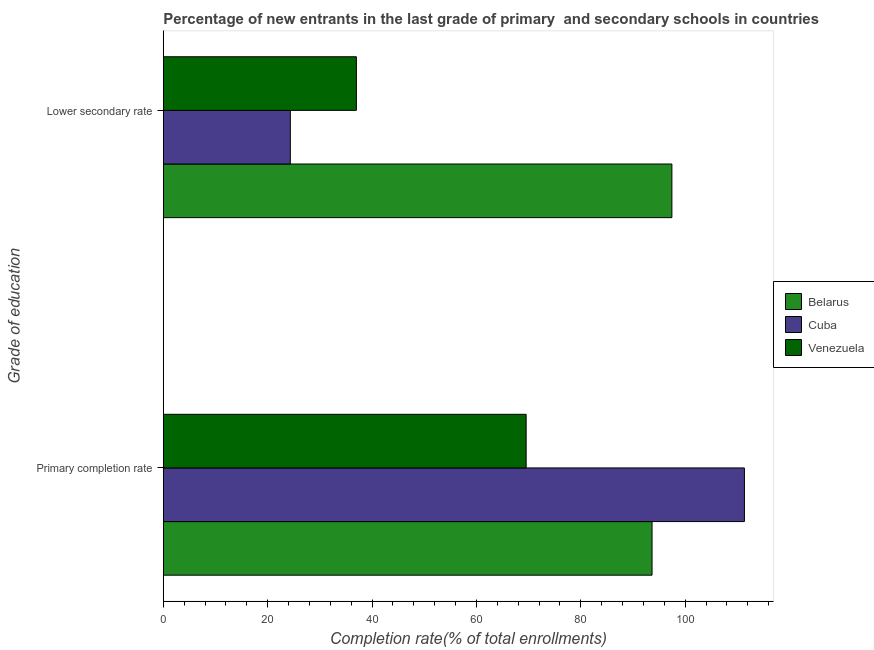How many different coloured bars are there?
Offer a very short reply. 3. How many bars are there on the 1st tick from the top?
Offer a terse response. 3. What is the label of the 1st group of bars from the top?
Ensure brevity in your answer.  Lower secondary rate. What is the completion rate in primary schools in Belarus?
Your answer should be very brief. 93.64. Across all countries, what is the maximum completion rate in primary schools?
Offer a terse response. 111.34. Across all countries, what is the minimum completion rate in secondary schools?
Provide a short and direct response. 24.34. In which country was the completion rate in secondary schools maximum?
Make the answer very short. Belarus. In which country was the completion rate in primary schools minimum?
Your response must be concise. Venezuela. What is the total completion rate in secondary schools in the graph?
Provide a succinct answer. 158.78. What is the difference between the completion rate in primary schools in Belarus and that in Venezuela?
Give a very brief answer. 24.12. What is the difference between the completion rate in primary schools in Venezuela and the completion rate in secondary schools in Cuba?
Give a very brief answer. 45.18. What is the average completion rate in primary schools per country?
Provide a succinct answer. 91.5. What is the difference between the completion rate in primary schools and completion rate in secondary schools in Cuba?
Your response must be concise. 87. What is the ratio of the completion rate in secondary schools in Belarus to that in Venezuela?
Your answer should be compact. 2.63. In how many countries, is the completion rate in secondary schools greater than the average completion rate in secondary schools taken over all countries?
Offer a terse response. 1. What does the 1st bar from the top in Lower secondary rate represents?
Your response must be concise. Venezuela. What does the 3rd bar from the bottom in Lower secondary rate represents?
Your answer should be compact. Venezuela. How many bars are there?
Ensure brevity in your answer.  6. How many countries are there in the graph?
Keep it short and to the point. 3. Where does the legend appear in the graph?
Make the answer very short. Center right. How many legend labels are there?
Your answer should be very brief. 3. How are the legend labels stacked?
Make the answer very short. Vertical. What is the title of the graph?
Offer a very short reply. Percentage of new entrants in the last grade of primary  and secondary schools in countries. What is the label or title of the X-axis?
Your answer should be very brief. Completion rate(% of total enrollments). What is the label or title of the Y-axis?
Give a very brief answer. Grade of education. What is the Completion rate(% of total enrollments) of Belarus in Primary completion rate?
Your answer should be very brief. 93.64. What is the Completion rate(% of total enrollments) in Cuba in Primary completion rate?
Provide a succinct answer. 111.34. What is the Completion rate(% of total enrollments) of Venezuela in Primary completion rate?
Your answer should be compact. 69.52. What is the Completion rate(% of total enrollments) in Belarus in Lower secondary rate?
Provide a succinct answer. 97.45. What is the Completion rate(% of total enrollments) in Cuba in Lower secondary rate?
Offer a terse response. 24.34. What is the Completion rate(% of total enrollments) in Venezuela in Lower secondary rate?
Your response must be concise. 37. Across all Grade of education, what is the maximum Completion rate(% of total enrollments) of Belarus?
Your answer should be very brief. 97.45. Across all Grade of education, what is the maximum Completion rate(% of total enrollments) of Cuba?
Make the answer very short. 111.34. Across all Grade of education, what is the maximum Completion rate(% of total enrollments) in Venezuela?
Give a very brief answer. 69.52. Across all Grade of education, what is the minimum Completion rate(% of total enrollments) in Belarus?
Your response must be concise. 93.64. Across all Grade of education, what is the minimum Completion rate(% of total enrollments) of Cuba?
Offer a very short reply. 24.34. Across all Grade of education, what is the minimum Completion rate(% of total enrollments) in Venezuela?
Keep it short and to the point. 37. What is the total Completion rate(% of total enrollments) in Belarus in the graph?
Make the answer very short. 191.09. What is the total Completion rate(% of total enrollments) in Cuba in the graph?
Your answer should be compact. 135.68. What is the total Completion rate(% of total enrollments) in Venezuela in the graph?
Your response must be concise. 106.52. What is the difference between the Completion rate(% of total enrollments) in Belarus in Primary completion rate and that in Lower secondary rate?
Your answer should be compact. -3.8. What is the difference between the Completion rate(% of total enrollments) in Cuba in Primary completion rate and that in Lower secondary rate?
Make the answer very short. 87. What is the difference between the Completion rate(% of total enrollments) in Venezuela in Primary completion rate and that in Lower secondary rate?
Provide a short and direct response. 32.52. What is the difference between the Completion rate(% of total enrollments) of Belarus in Primary completion rate and the Completion rate(% of total enrollments) of Cuba in Lower secondary rate?
Your answer should be compact. 69.31. What is the difference between the Completion rate(% of total enrollments) in Belarus in Primary completion rate and the Completion rate(% of total enrollments) in Venezuela in Lower secondary rate?
Give a very brief answer. 56.65. What is the difference between the Completion rate(% of total enrollments) of Cuba in Primary completion rate and the Completion rate(% of total enrollments) of Venezuela in Lower secondary rate?
Provide a succinct answer. 74.35. What is the average Completion rate(% of total enrollments) in Belarus per Grade of education?
Give a very brief answer. 95.55. What is the average Completion rate(% of total enrollments) in Cuba per Grade of education?
Make the answer very short. 67.84. What is the average Completion rate(% of total enrollments) of Venezuela per Grade of education?
Your answer should be very brief. 53.26. What is the difference between the Completion rate(% of total enrollments) of Belarus and Completion rate(% of total enrollments) of Cuba in Primary completion rate?
Make the answer very short. -17.7. What is the difference between the Completion rate(% of total enrollments) in Belarus and Completion rate(% of total enrollments) in Venezuela in Primary completion rate?
Your response must be concise. 24.12. What is the difference between the Completion rate(% of total enrollments) in Cuba and Completion rate(% of total enrollments) in Venezuela in Primary completion rate?
Provide a short and direct response. 41.82. What is the difference between the Completion rate(% of total enrollments) of Belarus and Completion rate(% of total enrollments) of Cuba in Lower secondary rate?
Offer a terse response. 73.11. What is the difference between the Completion rate(% of total enrollments) in Belarus and Completion rate(% of total enrollments) in Venezuela in Lower secondary rate?
Your response must be concise. 60.45. What is the difference between the Completion rate(% of total enrollments) of Cuba and Completion rate(% of total enrollments) of Venezuela in Lower secondary rate?
Your answer should be very brief. -12.66. What is the ratio of the Completion rate(% of total enrollments) of Belarus in Primary completion rate to that in Lower secondary rate?
Keep it short and to the point. 0.96. What is the ratio of the Completion rate(% of total enrollments) in Cuba in Primary completion rate to that in Lower secondary rate?
Your answer should be very brief. 4.57. What is the ratio of the Completion rate(% of total enrollments) in Venezuela in Primary completion rate to that in Lower secondary rate?
Your answer should be compact. 1.88. What is the difference between the highest and the second highest Completion rate(% of total enrollments) of Belarus?
Offer a terse response. 3.8. What is the difference between the highest and the second highest Completion rate(% of total enrollments) of Cuba?
Make the answer very short. 87. What is the difference between the highest and the second highest Completion rate(% of total enrollments) of Venezuela?
Ensure brevity in your answer.  32.52. What is the difference between the highest and the lowest Completion rate(% of total enrollments) of Belarus?
Offer a very short reply. 3.8. What is the difference between the highest and the lowest Completion rate(% of total enrollments) in Cuba?
Your answer should be very brief. 87. What is the difference between the highest and the lowest Completion rate(% of total enrollments) of Venezuela?
Give a very brief answer. 32.52. 